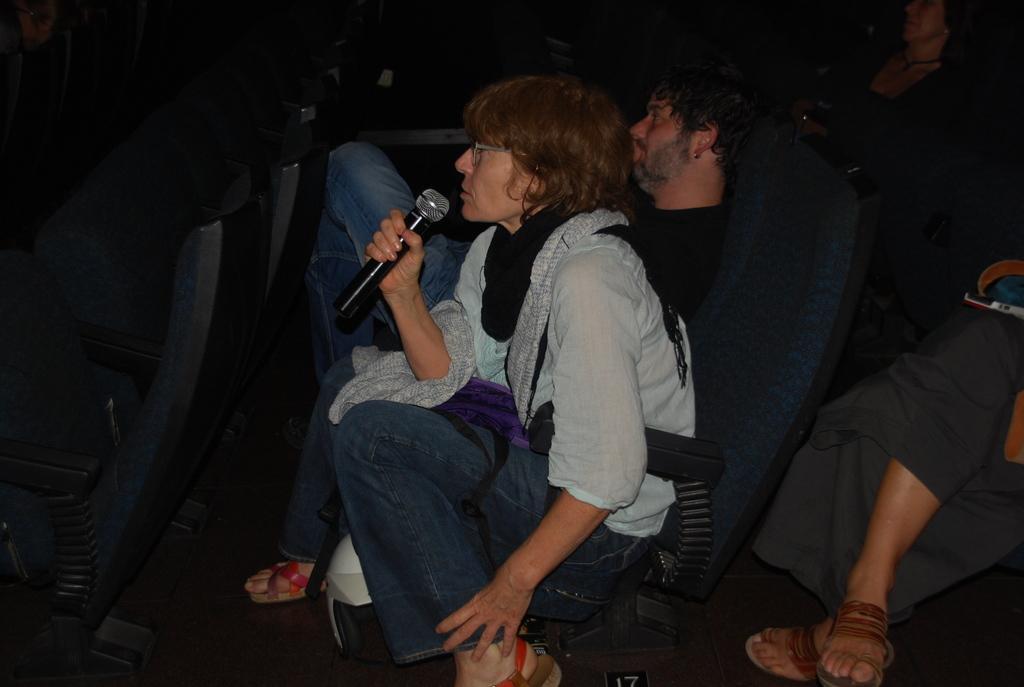How would you summarize this image in a sentence or two? In this image, I can see few people sitting on the chairs. Among them one person is holding a mike. On the right side of the image, I can see the legs of a person. At the bottom of the image, It looks like a helmet, which is on the floor. On the left side of the image, there are empty chairs. 